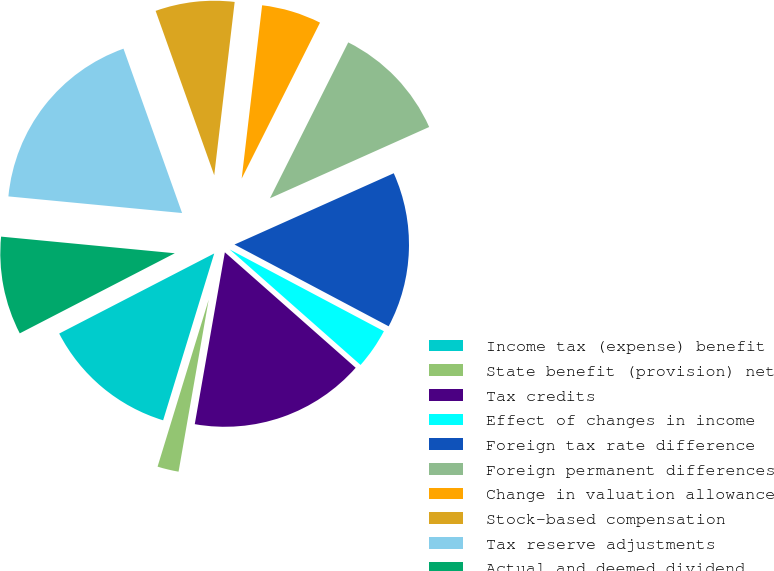Convert chart. <chart><loc_0><loc_0><loc_500><loc_500><pie_chart><fcel>Income tax (expense) benefit<fcel>State benefit (provision) net<fcel>Tax credits<fcel>Effect of changes in income<fcel>Foreign tax rate difference<fcel>Foreign permanent differences<fcel>Change in valuation allowance<fcel>Stock-based compensation<fcel>Tax reserve adjustments<fcel>Actual and deemed dividend<nl><fcel>12.68%<fcel>1.97%<fcel>16.25%<fcel>3.75%<fcel>14.46%<fcel>10.89%<fcel>5.54%<fcel>7.32%<fcel>18.03%<fcel>9.11%<nl></chart> 